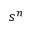Convert formula to latex. <formula><loc_0><loc_0><loc_500><loc_500>s ^ { n }</formula> 